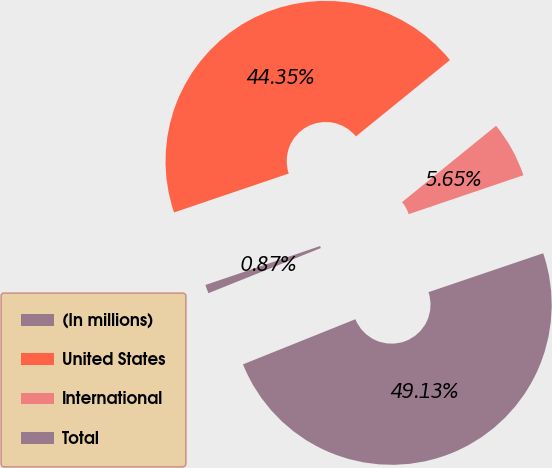Convert chart. <chart><loc_0><loc_0><loc_500><loc_500><pie_chart><fcel>(In millions)<fcel>United States<fcel>International<fcel>Total<nl><fcel>0.87%<fcel>44.35%<fcel>5.65%<fcel>49.13%<nl></chart> 